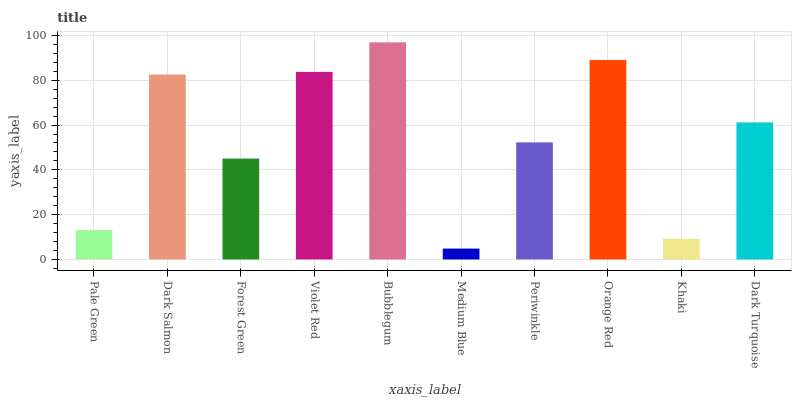Is Medium Blue the minimum?
Answer yes or no. Yes. Is Bubblegum the maximum?
Answer yes or no. Yes. Is Dark Salmon the minimum?
Answer yes or no. No. Is Dark Salmon the maximum?
Answer yes or no. No. Is Dark Salmon greater than Pale Green?
Answer yes or no. Yes. Is Pale Green less than Dark Salmon?
Answer yes or no. Yes. Is Pale Green greater than Dark Salmon?
Answer yes or no. No. Is Dark Salmon less than Pale Green?
Answer yes or no. No. Is Dark Turquoise the high median?
Answer yes or no. Yes. Is Periwinkle the low median?
Answer yes or no. Yes. Is Orange Red the high median?
Answer yes or no. No. Is Medium Blue the low median?
Answer yes or no. No. 